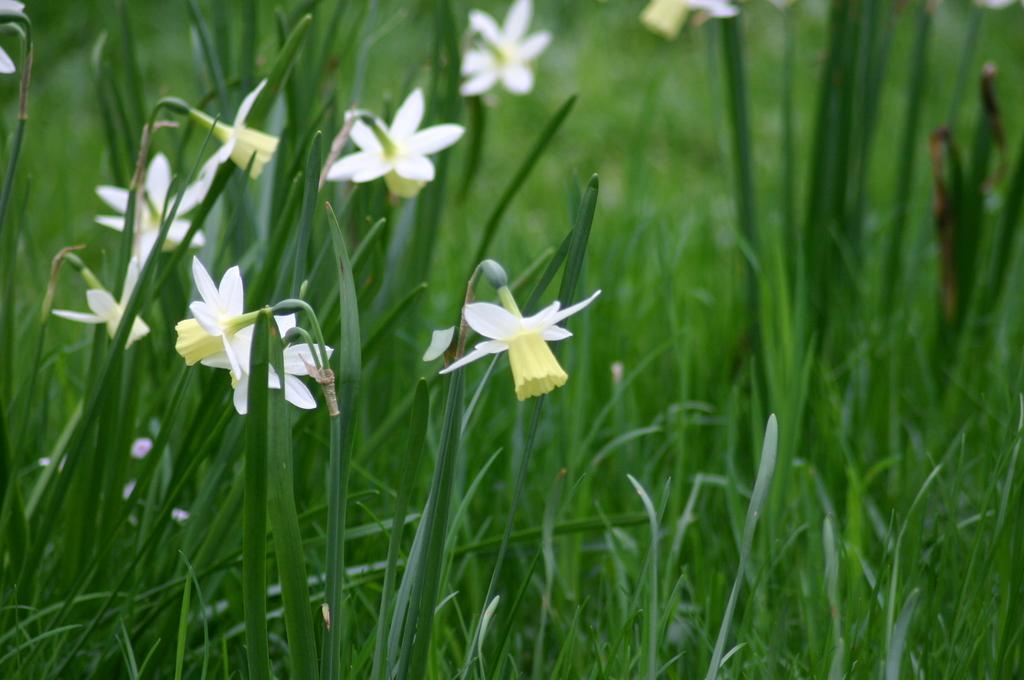In one or two sentences, can you explain what this image depicts? In this image we can see group of flowers and leaves. 